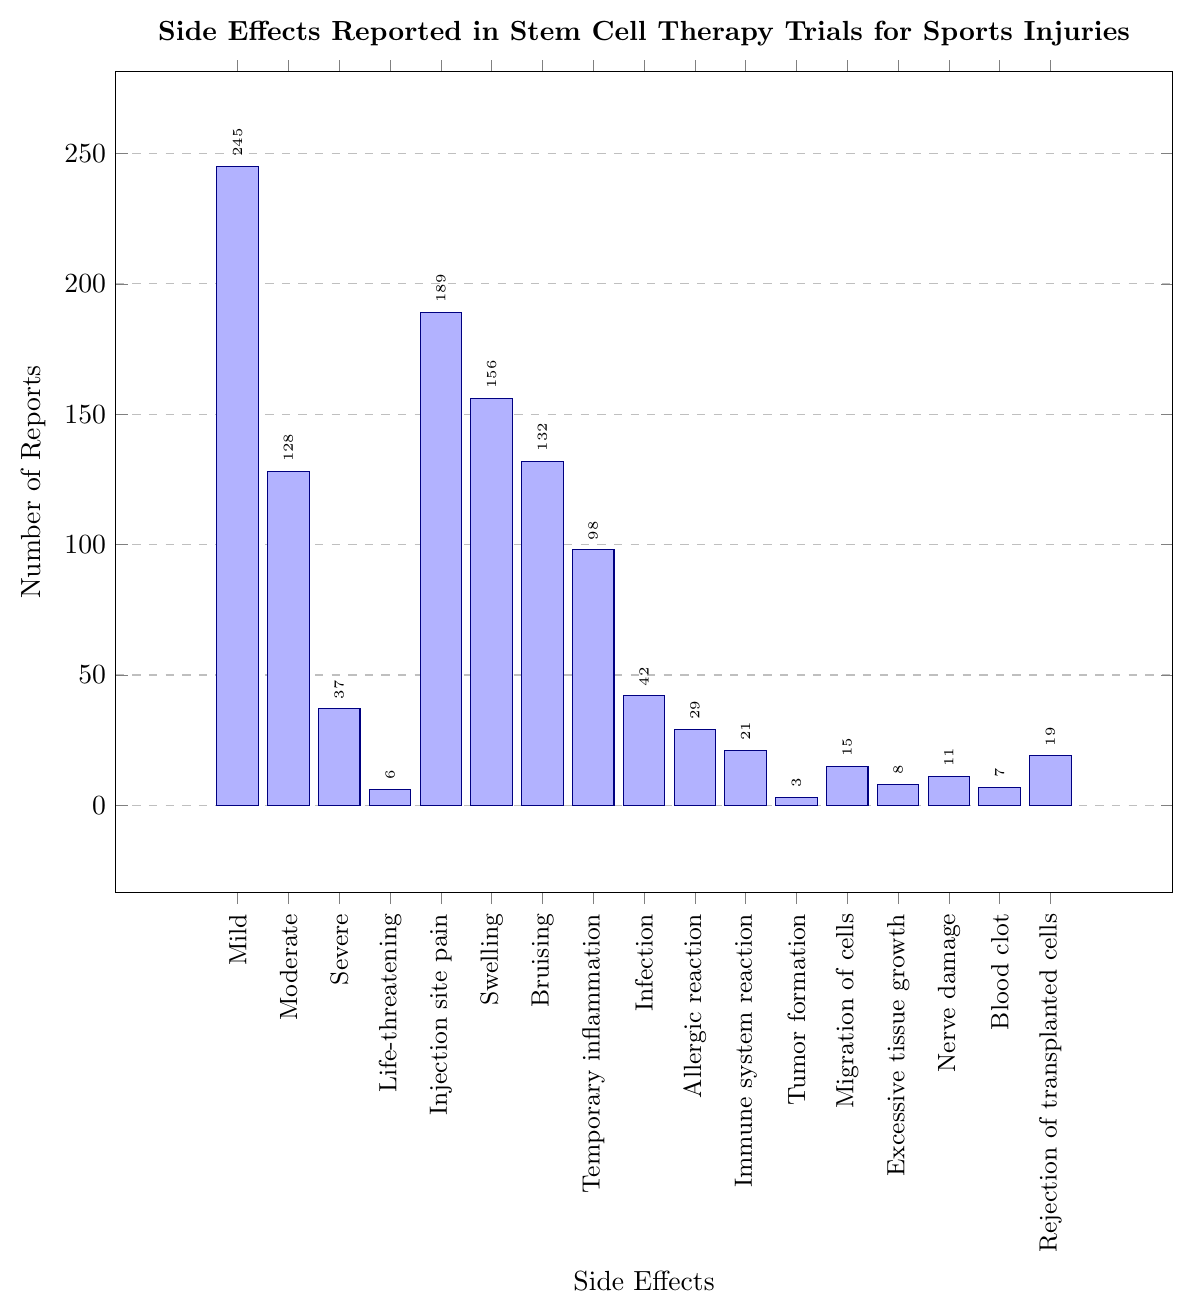What is the total number of reports for Severe and Life-threatening side effects combined? Look at the bars for "Severe" and "Life-threatening". The "Severe" bar has 37 reports and the "Life-threatening" bar has 6 reports. Add the two numbers together: 37 + 6.
Answer: 43 Which side effect has the highest number of reports? Identify the tallest bar in the chart. The "Mild" side effect has the highest bar, with 245 reports.
Answer: Mild How many more reports are there for Mild compared to Moderate side effects? Find the values of "Mild" and "Moderate" bars. "Mild" has 245 reports and "Moderate" has 128 reports. Subtract the reports for "Moderate" from "Mild": 245 - 128.
Answer: 117 What is the average number of reports for Injection site pain, Swelling, and Bruising? Find the number of reports for each: "Injection site pain" (189), "Swelling" (156), and "Bruising" (132). Add the three values and divide by 3: (189 + 156 + 132) / 3.
Answer: 159 Are there more reports of Nerve damage or Blood clot? Compare the heights of "Nerve damage" and "Blood clot". "Nerve damage" has 11 reports, and "Blood clot" has 7 reports.
Answer: Nerve damage How does the number of reports for Temporary inflammation compare to that for Infection? Extract the numbers for "Temporary inflammation" (98) and "Infection" (42). Compare these values.
Answer: Temporary inflammation is higher What is the sum of reports for Injection site pain and Swelling? Find the numbers of reports for each: "Injection site pain" is 189 and "Swelling" is 156. Add them together: 189 + 156.
Answer: 345 Which side effect has fewer reports: Immune system reaction or Allergic reaction? Compare "Immune system reaction" (21) and "Allergic reaction" (29).
Answer: Immune system reaction What is the median number of reports among Severe, Life-threatening, and Infection? Arrange the number of reports (Severe: 37, Life-threatening: 6, Infection: 42) in ascending order (6, 37, 42). The middle value is the median.
Answer: 37 How many side effects reported less than 20 times? Name them. Identify bars with values less than 20. These bars are "Life-threatening" (6), "Tumor formation" (3), "Migration of cells" (15), "Excessive tissue growth" (8), "Nerve damage" (11), "Blood clot" (7), and "Rejection of transplanted cells" (19). Count and list them.
Answer: 7; Life-threatening, Tumor formation, Migration of cells, Excessive tissue growth, Nerve damage, Blood clot, Rejection of transplanted cells 